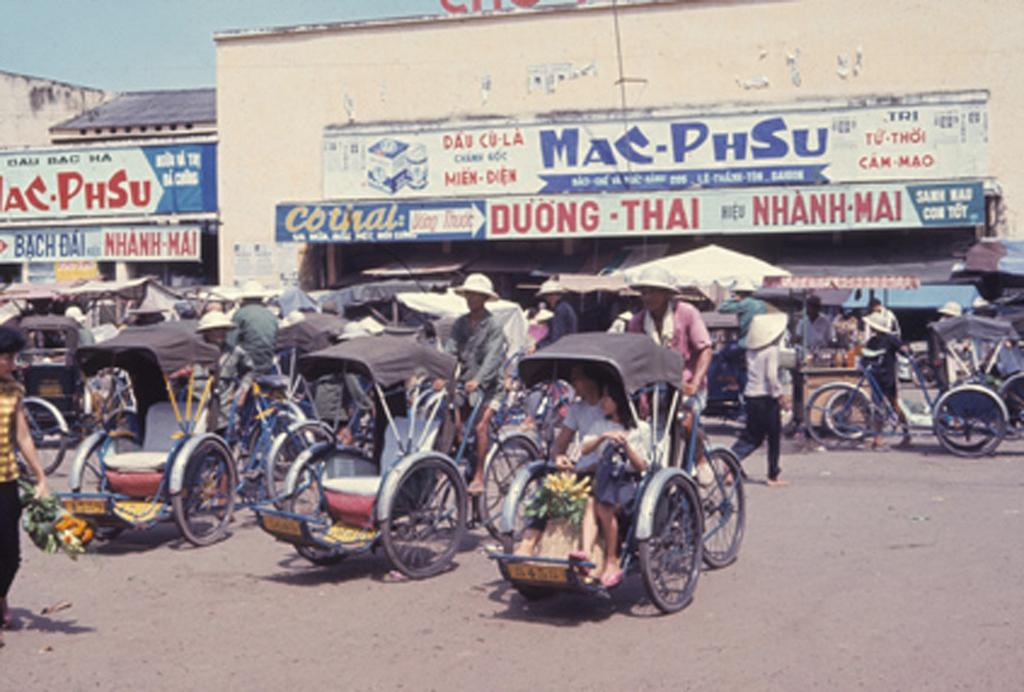What is happening on the road in the image? There are vehicles on the road in the image. What else can be seen in the image besides vehicles? There are people walking in the image. What can be seen in the distance in the image? There are buildings visible in the background of the image. How many beans are present in the image? There are no beans present in the image. What type of things can be seen in the front of the image? The provided facts do not mention anything specific about the front of the image, so it is impossible to answer this question definitively. 